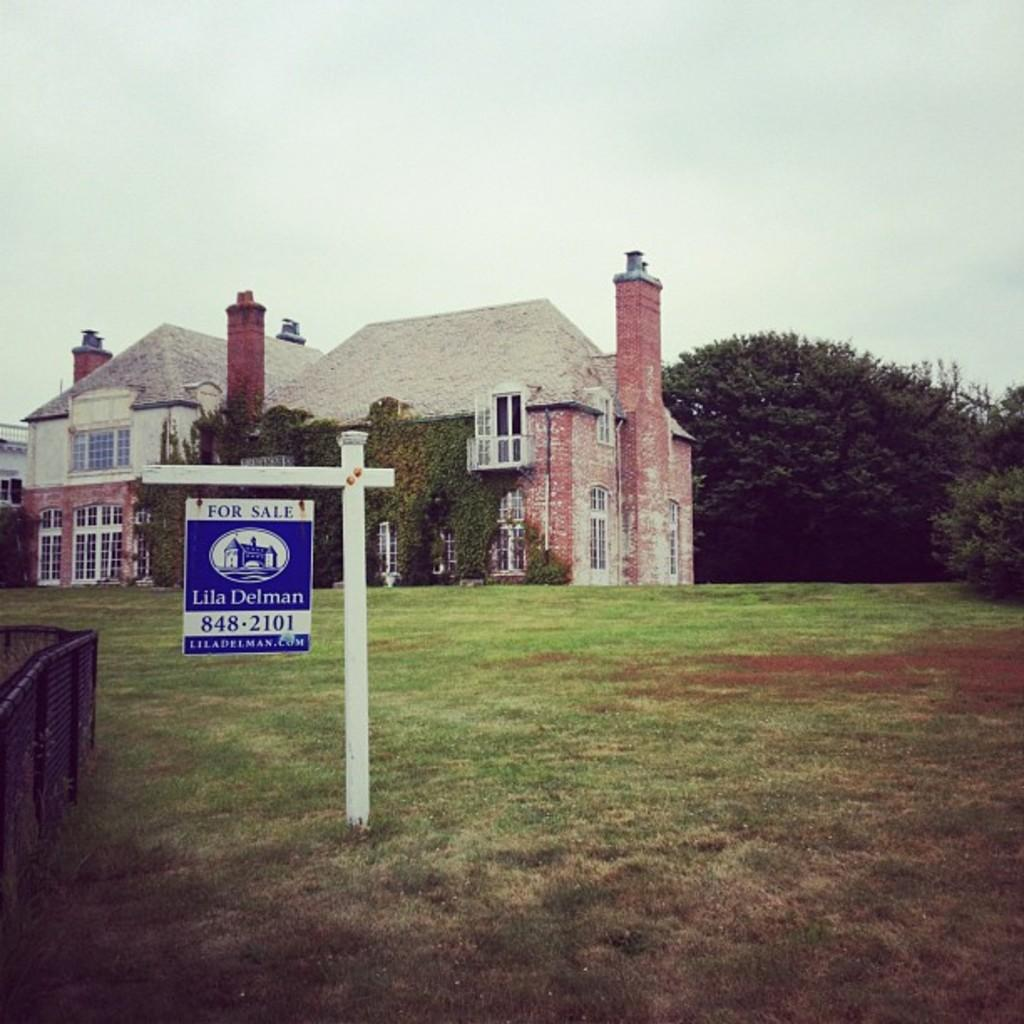What type of structure is visible in the image? There is a building in the image. What is attached to the pole in the image? There is a board with text attached to the pole in the image. What type of vegetation is present can be seen in the image? There are trees and creepers visible in the image. What architectural feature can be seen in the image? There are windows in the image. What type of barrier is present in the image? There is a fence in the image. What can be seen in the background of the image? The sky is visible in the background of the image. Who is the representative arguing with the addition of new policies in the image? There is no representative or argument present in the image; it features a building, a pole with a board and text, trees, creepers, windows, a fence, and the sky visible in the background. 